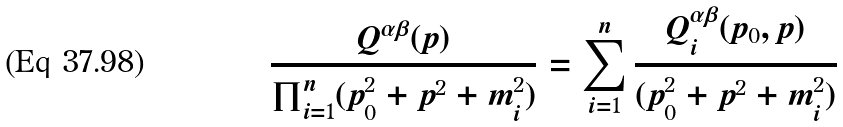<formula> <loc_0><loc_0><loc_500><loc_500>\frac { Q ^ { \alpha \beta } ( p ) } { \prod _ { i = 1 } ^ { n } ( p _ { 0 } ^ { 2 } + { p } ^ { 2 } + m _ { i } ^ { 2 } ) } = \sum _ { i = 1 } ^ { n } \frac { Q ^ { \alpha \beta } _ { i } ( p _ { 0 } , { p } ) } { ( p _ { 0 } ^ { 2 } + { p } ^ { 2 } + m _ { i } ^ { 2 } ) }</formula> 